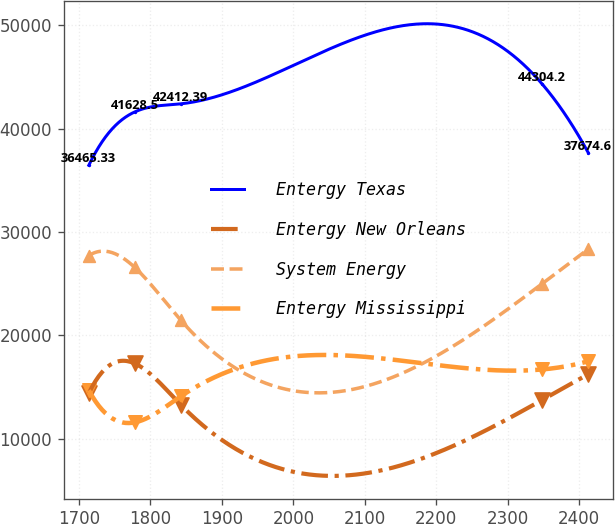<chart> <loc_0><loc_0><loc_500><loc_500><line_chart><ecel><fcel>Entergy Texas<fcel>Entergy New Orleans<fcel>System Energy<fcel>Entergy Mississippi<nl><fcel>1713.87<fcel>36465.3<fcel>14401.2<fcel>27724.3<fcel>14678.4<nl><fcel>1778.07<fcel>41628.5<fcel>17282.1<fcel>26581.3<fcel>11577.1<nl><fcel>1842.27<fcel>42412.4<fcel>13298.7<fcel>21486.5<fcel>14086.5<nl><fcel>2348.45<fcel>44304.2<fcel>13757.6<fcel>25017.8<fcel>16703<nl><fcel>2412.65<fcel>37674.6<fcel>16242<fcel>28354.1<fcel>17496<nl></chart> 